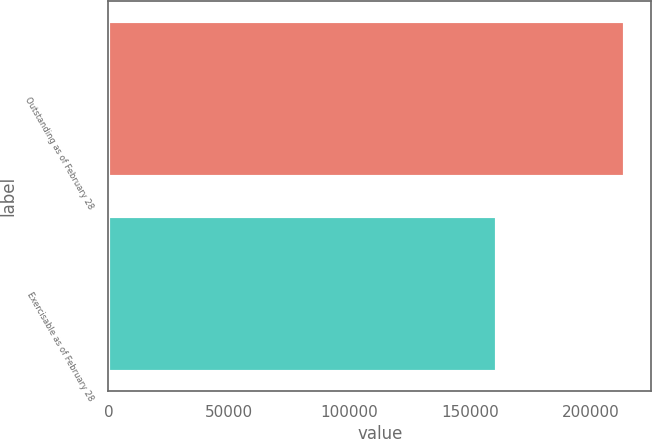Convert chart to OTSL. <chart><loc_0><loc_0><loc_500><loc_500><bar_chart><fcel>Outstanding as of February 28<fcel>Exercisable as of February 28<nl><fcel>214476<fcel>161051<nl></chart> 